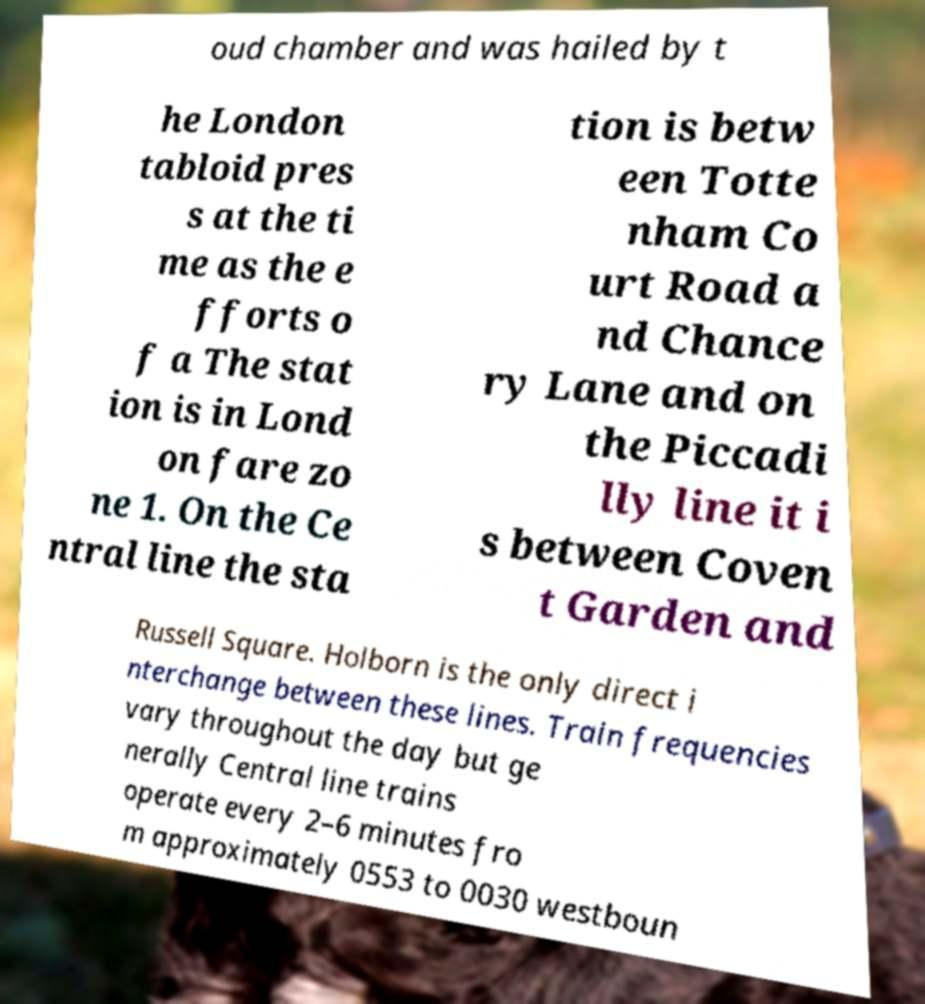Can you read and provide the text displayed in the image?This photo seems to have some interesting text. Can you extract and type it out for me? oud chamber and was hailed by t he London tabloid pres s at the ti me as the e fforts o f a The stat ion is in Lond on fare zo ne 1. On the Ce ntral line the sta tion is betw een Totte nham Co urt Road a nd Chance ry Lane and on the Piccadi lly line it i s between Coven t Garden and Russell Square. Holborn is the only direct i nterchange between these lines. Train frequencies vary throughout the day but ge nerally Central line trains operate every 2–6 minutes fro m approximately 0553 to 0030 westboun 